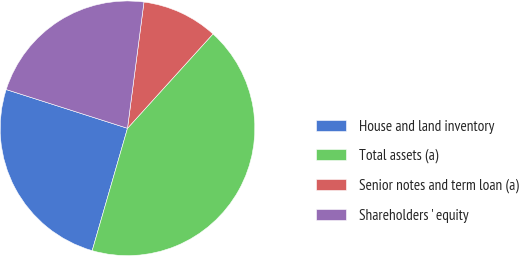Convert chart to OTSL. <chart><loc_0><loc_0><loc_500><loc_500><pie_chart><fcel>House and land inventory<fcel>Total assets (a)<fcel>Senior notes and term loan (a)<fcel>Shareholders ' equity<nl><fcel>25.45%<fcel>42.75%<fcel>9.65%<fcel>22.14%<nl></chart> 